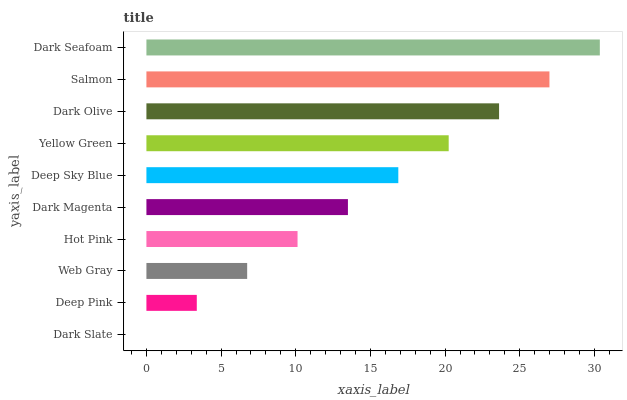Is Dark Slate the minimum?
Answer yes or no. Yes. Is Dark Seafoam the maximum?
Answer yes or no. Yes. Is Deep Pink the minimum?
Answer yes or no. No. Is Deep Pink the maximum?
Answer yes or no. No. Is Deep Pink greater than Dark Slate?
Answer yes or no. Yes. Is Dark Slate less than Deep Pink?
Answer yes or no. Yes. Is Dark Slate greater than Deep Pink?
Answer yes or no. No. Is Deep Pink less than Dark Slate?
Answer yes or no. No. Is Deep Sky Blue the high median?
Answer yes or no. Yes. Is Dark Magenta the low median?
Answer yes or no. Yes. Is Dark Seafoam the high median?
Answer yes or no. No. Is Dark Seafoam the low median?
Answer yes or no. No. 